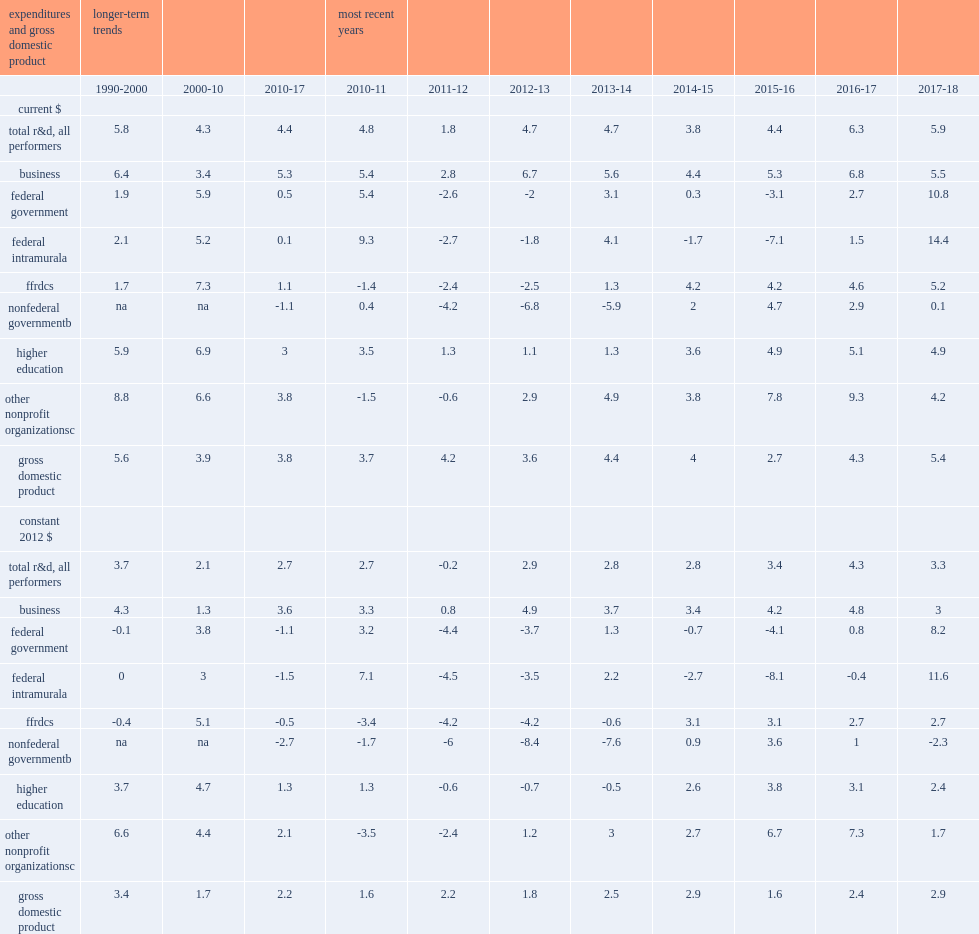Adjusted for inflation, how many percent of growth in u.s. total r&d averaged annually over the 2010-17 period? 2.7. How many percent of average growth of u.s. gross domestic product (gdp)? 2.2. How many percent of average annual growth of u.s. total r&d in the prior decade (2000-10)? 2.1. How many percent of average growth of u.s. gross domestic product (gdp) in the prior decade (2000-10)? 1.7. How many percent of average annual growth of u.s. total r&d in the prior decade (2017-18)? 3.3. What was the rate of u.s. gross domestic product (gdp) expansion in the prior decade (2017-18)? 2.9. 